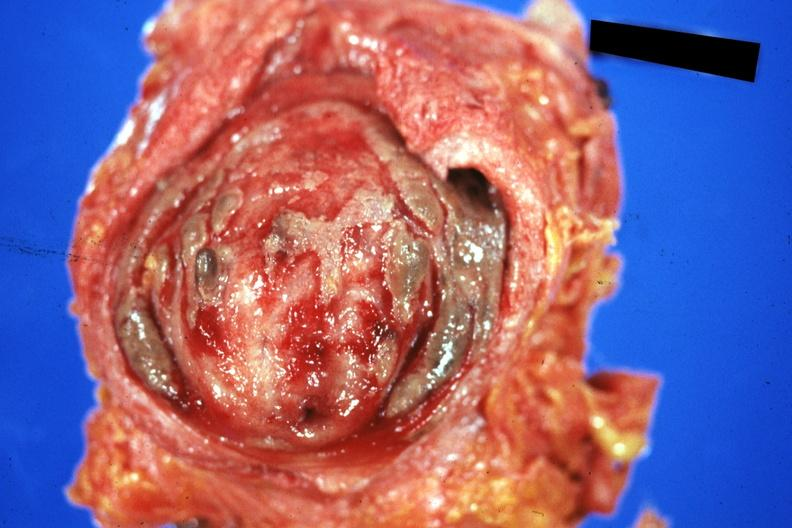s premature coronary disease present?
Answer the question using a single word or phrase. No 